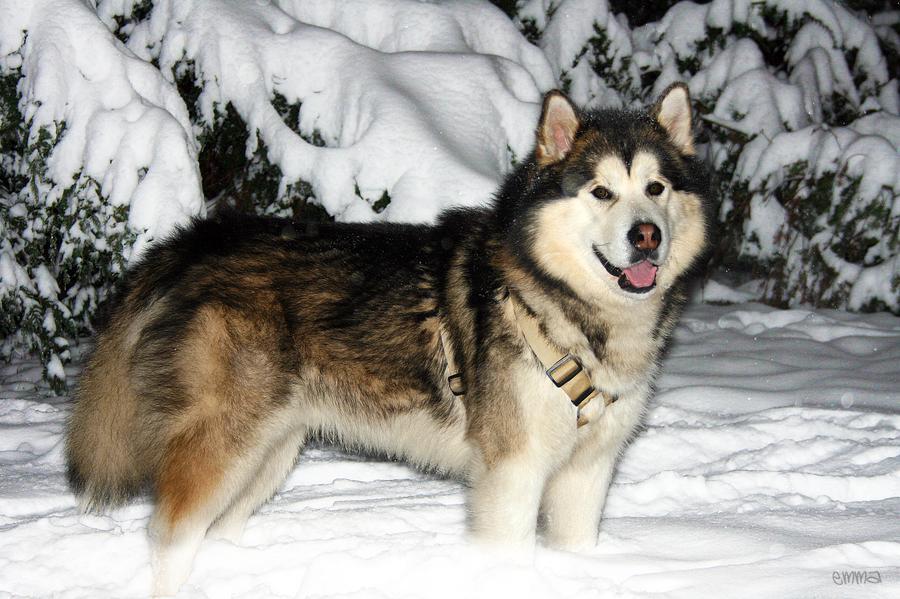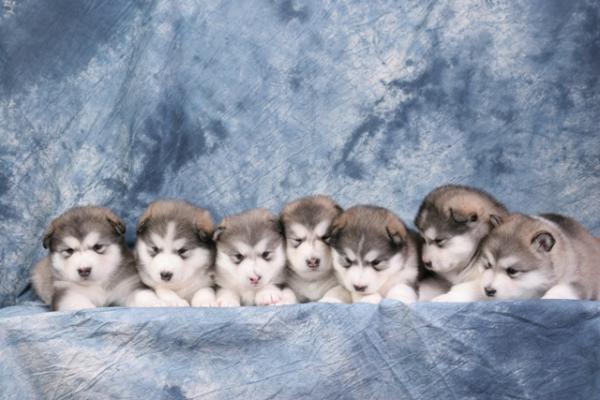The first image is the image on the left, the second image is the image on the right. For the images displayed, is the sentence "There are at most three dogs in total." factually correct? Answer yes or no. No. The first image is the image on the left, the second image is the image on the right. Given the left and right images, does the statement "One of the images contains exactly two dogs." hold true? Answer yes or no. No. 